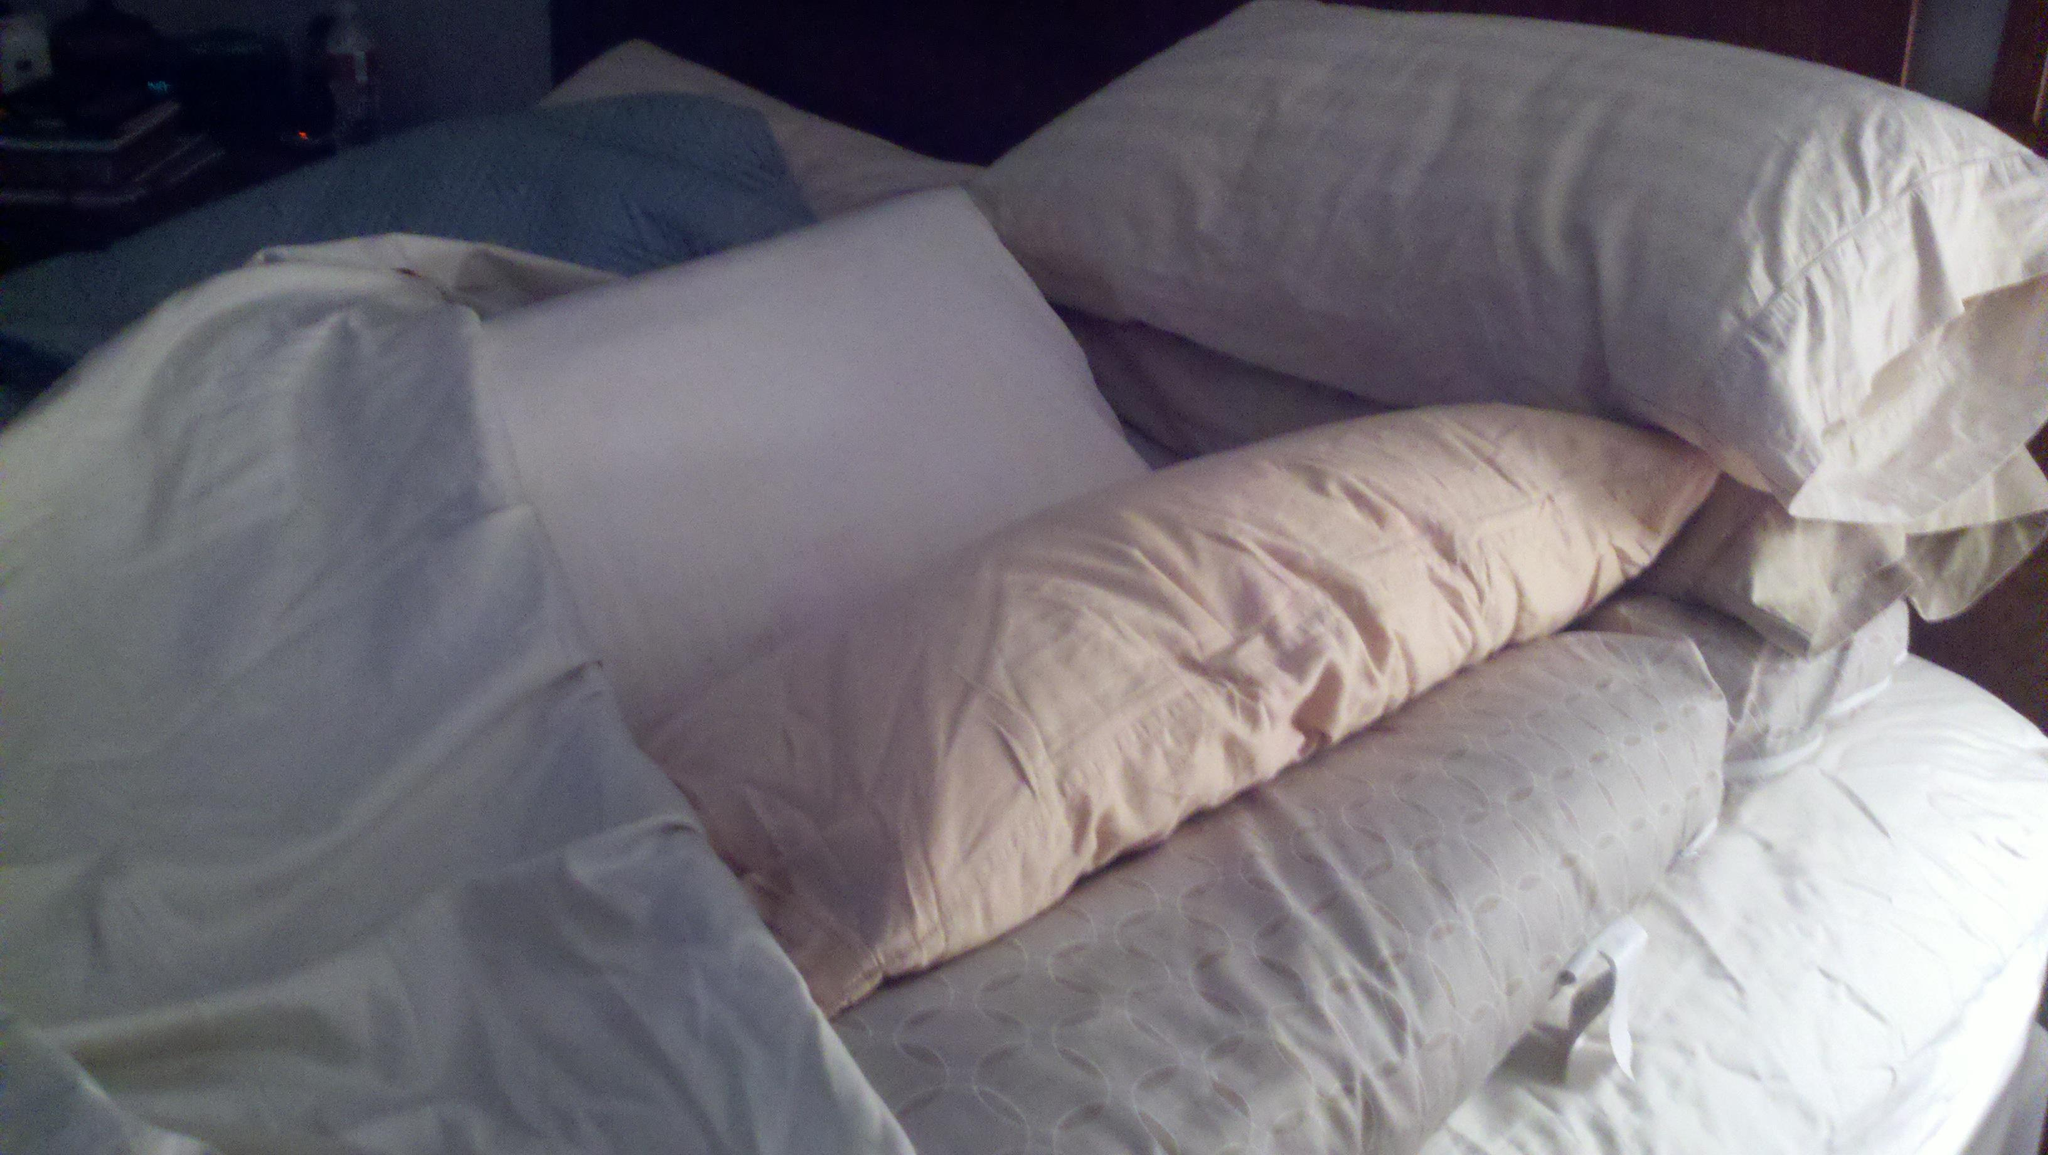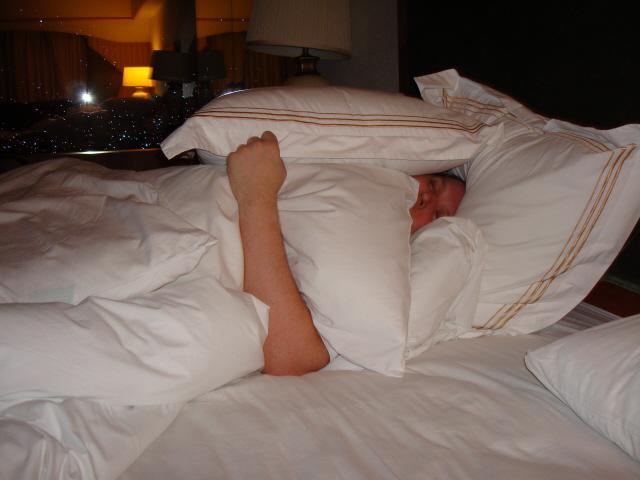The first image is the image on the left, the second image is the image on the right. Given the left and right images, does the statement "In one of the images there is just one person lying in bed with multiple pillows." hold true? Answer yes or no. Yes. 